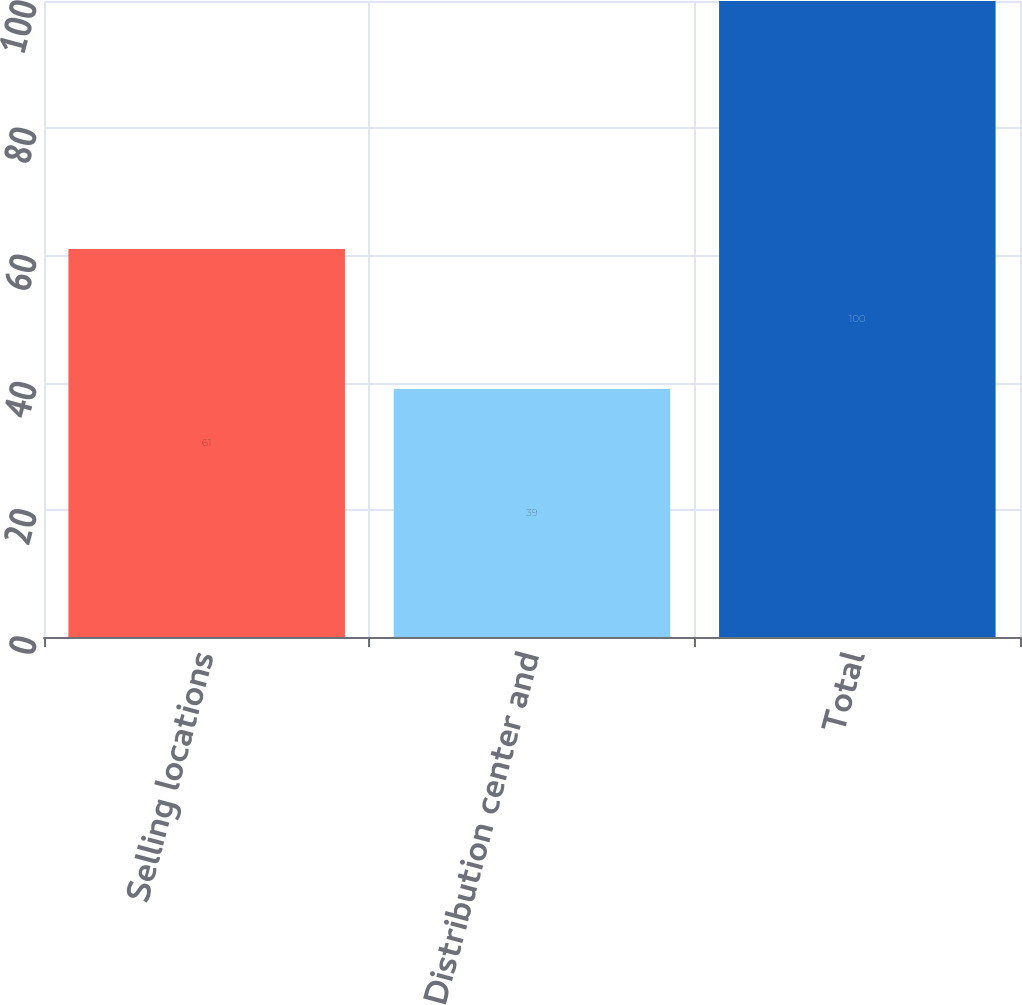Convert chart to OTSL. <chart><loc_0><loc_0><loc_500><loc_500><bar_chart><fcel>Selling locations<fcel>Distribution center and<fcel>Total<nl><fcel>61<fcel>39<fcel>100<nl></chart> 